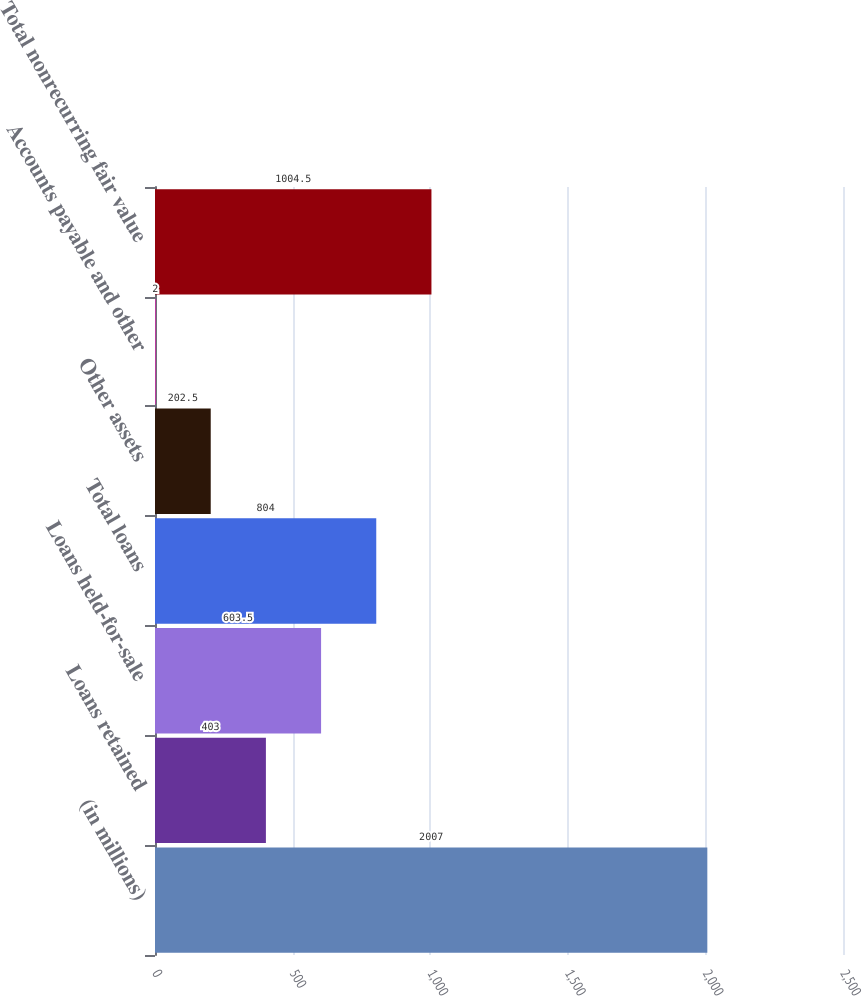Convert chart. <chart><loc_0><loc_0><loc_500><loc_500><bar_chart><fcel>(in millions)<fcel>Loans retained<fcel>Loans held-for-sale<fcel>Total loans<fcel>Other assets<fcel>Accounts payable and other<fcel>Total nonrecurring fair value<nl><fcel>2007<fcel>403<fcel>603.5<fcel>804<fcel>202.5<fcel>2<fcel>1004.5<nl></chart> 